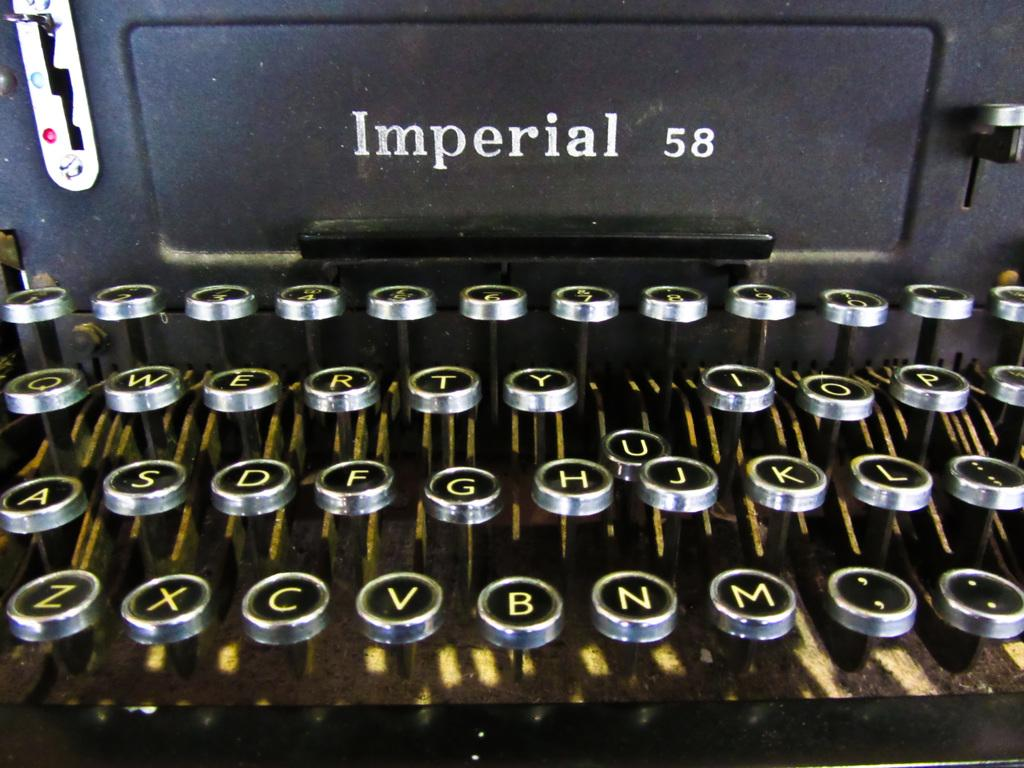<image>
Relay a brief, clear account of the picture shown. An Imperial 58 typewriter that is black with silver buttons. 